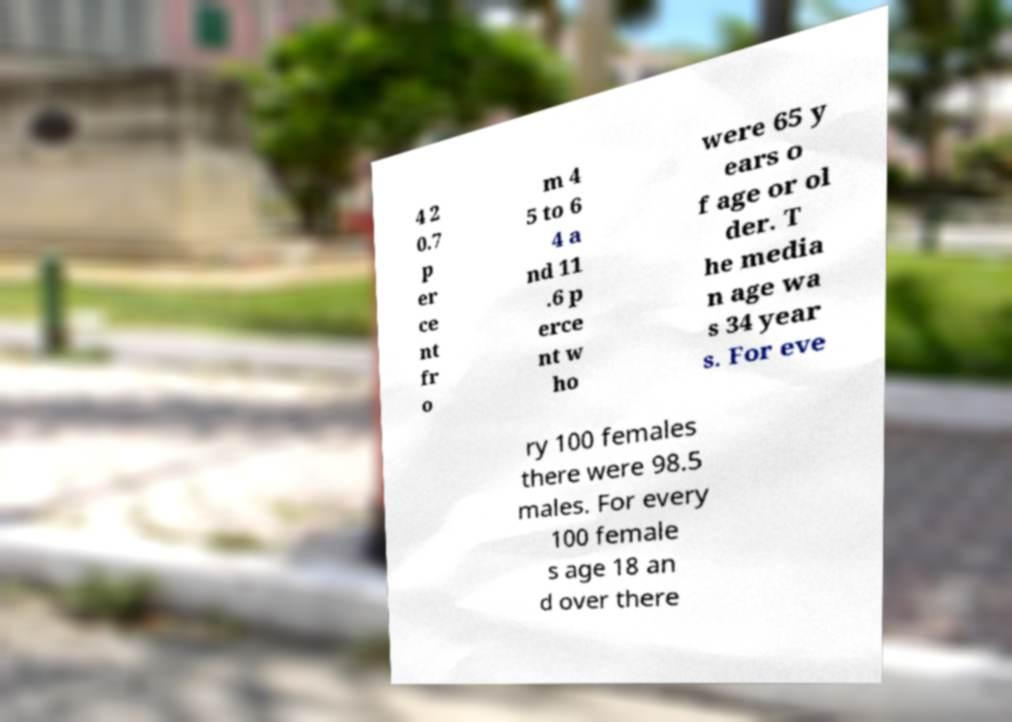Please read and relay the text visible in this image. What does it say? 4 2 0.7 p er ce nt fr o m 4 5 to 6 4 a nd 11 .6 p erce nt w ho were 65 y ears o f age or ol der. T he media n age wa s 34 year s. For eve ry 100 females there were 98.5 males. For every 100 female s age 18 an d over there 